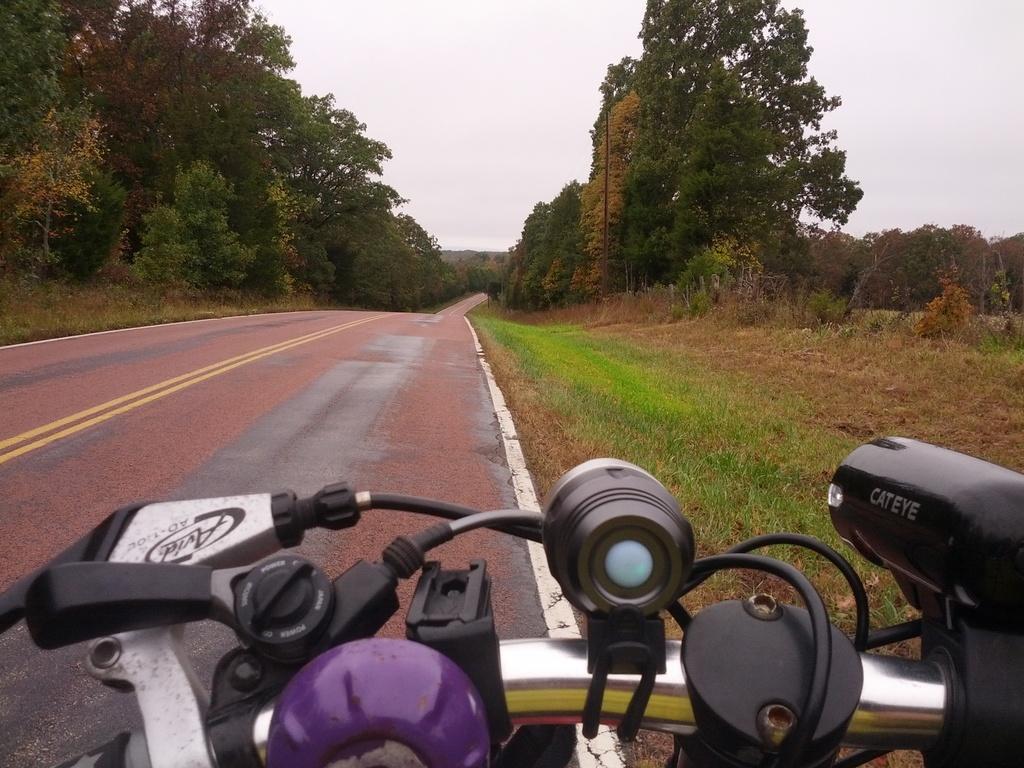Describe this image in one or two sentences. In the foreground I can see a vehicle on the road. In the background I can see grass, trees and the sky. This image is taken may be on the road. 